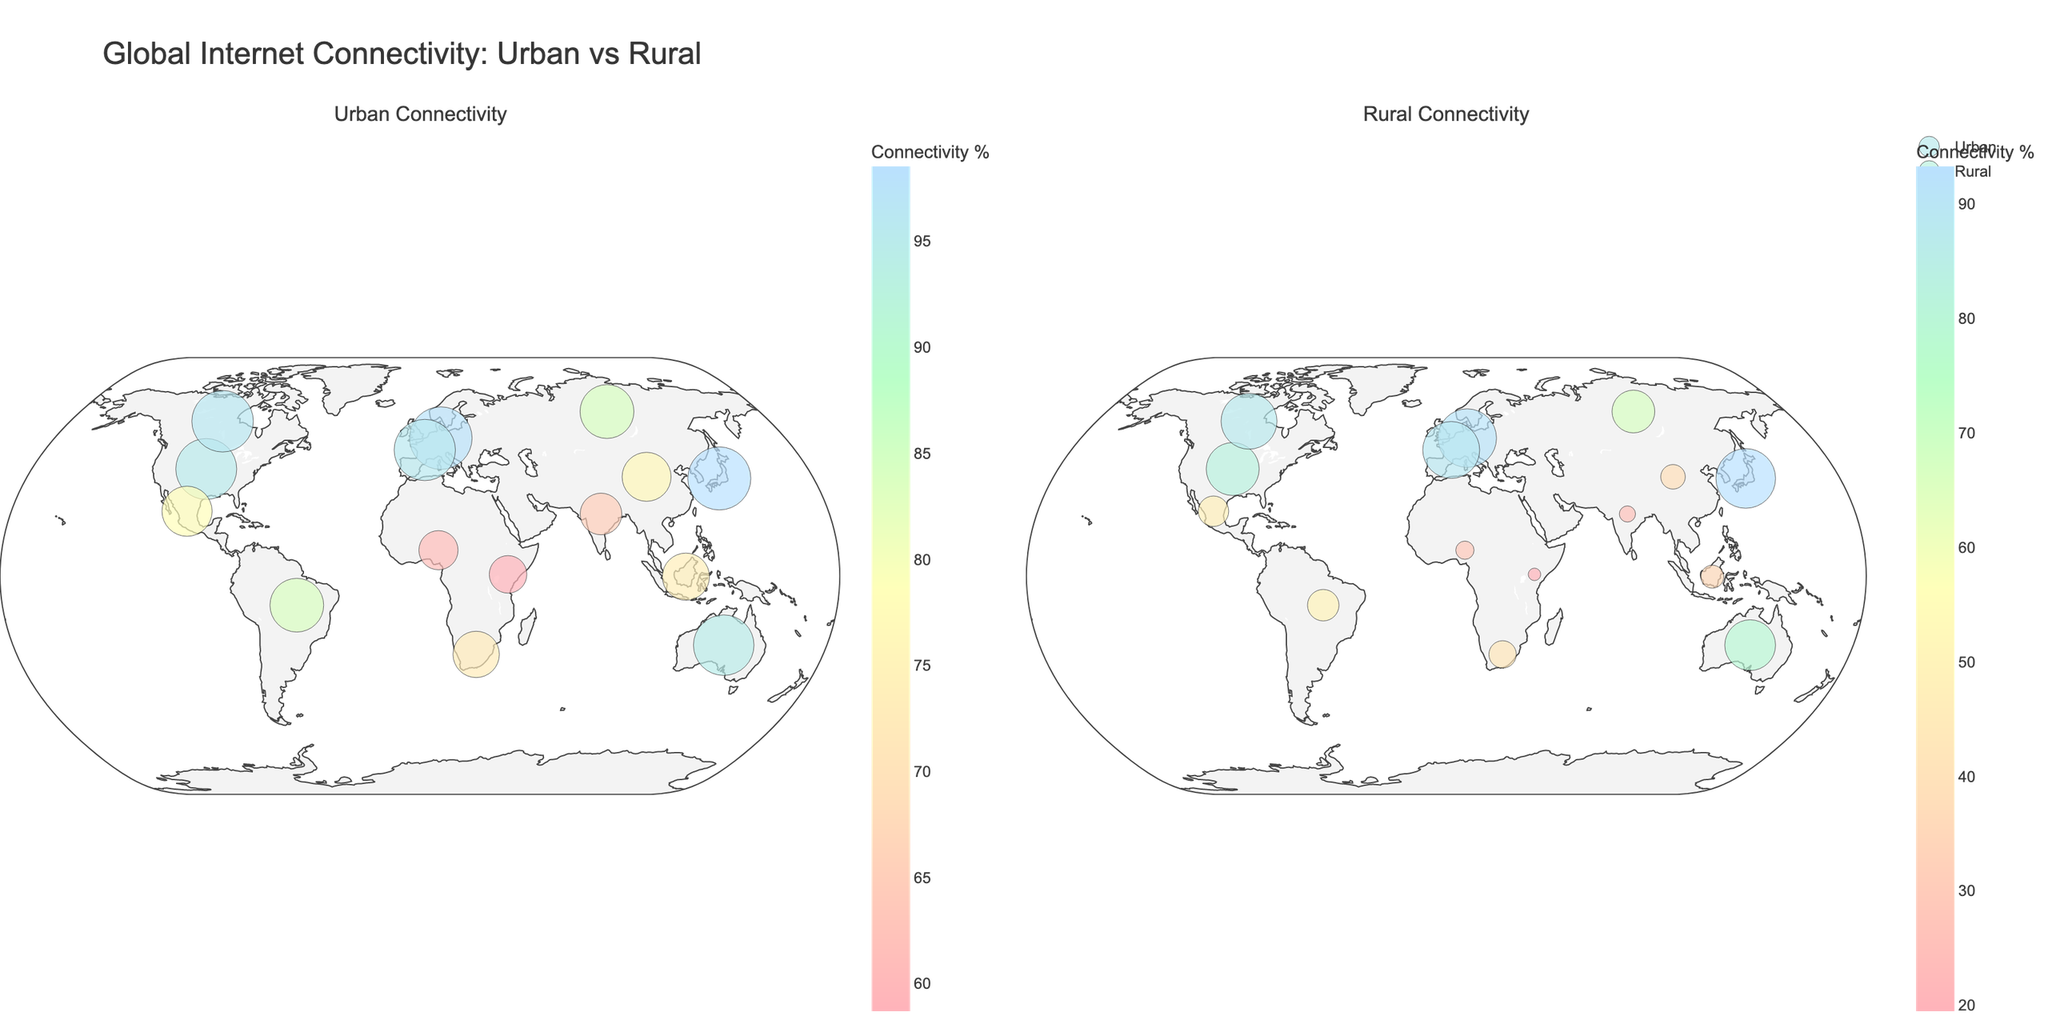What is the title of the figure? The title can be found at the top of the figure. It is labeled as "Global Internet Connectivity: Urban vs Rural".
Answer: Global Internet Connectivity: Urban vs Rural How many countries are shown in the figure? You can count the number of countries listed in the plot. There are a total of 15 countries displayed.
Answer: 15 Which country has the highest urban connectivity rate? By examining the urban connectivity plot, Japan has the highest rate at 98.5%.
Answer: Japan Which country has the lowest rural connectivity rate? By checking the rural connectivity plot, Kenya has the lowest rate at 19.5%.
Answer: Kenya What is the difference in rural connectivity rates between Germany and India? Look at the rural connectivity rates for both countries: Germany (91.5%) and India (25.3%). Subtract India's rate from Germany's to find the difference. 91.5% - 25.3% = 66.2%.
Answer: 66.2% What is the average connectivity rate for urban areas across all countries? Add all the urban connectivity rates and divide by the number of countries: (95.2 + 76.5 + 65.1 + 83.9 + 61.2 + 97.8 + 73.7 + 98.5 + 78.3 + 72.4 + 94.6 + 58.7 + 96.1 + 84.2 + 95.7) / 15 = 81.56%.
Answer: 81.56% Which country has a greater disparity between urban and rural connectivity rates: China or Brazil? Calculate the difference for both countries. China: 76.5% - 38.4% = 38.1%. Brazil: 83.9% - 49.2% = 34.7%. China has a greater disparity.
Answer: China Are there any countries where both urban and rural connectivity rates are above 90%? Check both plots. Germany (97.8% urban, 91.5% rural), Japan (98.5% urban, 93.2% rural), and France (95.7% urban, 88.9% rural) have high rates, but rural rates for France are below 90%. Only Germany and Japan fulfill both conditions.
Answer: Germany and Japan 